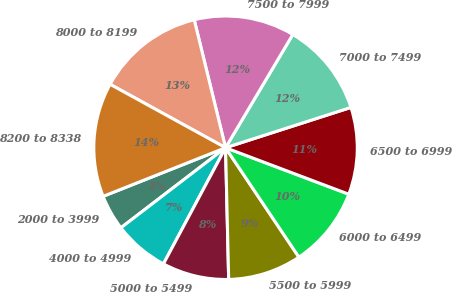Convert chart. <chart><loc_0><loc_0><loc_500><loc_500><pie_chart><fcel>2000 to 3999<fcel>4000 to 4999<fcel>5000 to 5499<fcel>5500 to 5999<fcel>6000 to 6499<fcel>6500 to 6999<fcel>7000 to 7499<fcel>7500 to 7999<fcel>8000 to 8199<fcel>8200 to 8338<nl><fcel>4.38%<fcel>6.79%<fcel>8.19%<fcel>9.02%<fcel>9.86%<fcel>10.69%<fcel>11.52%<fcel>12.35%<fcel>13.18%<fcel>14.01%<nl></chart> 